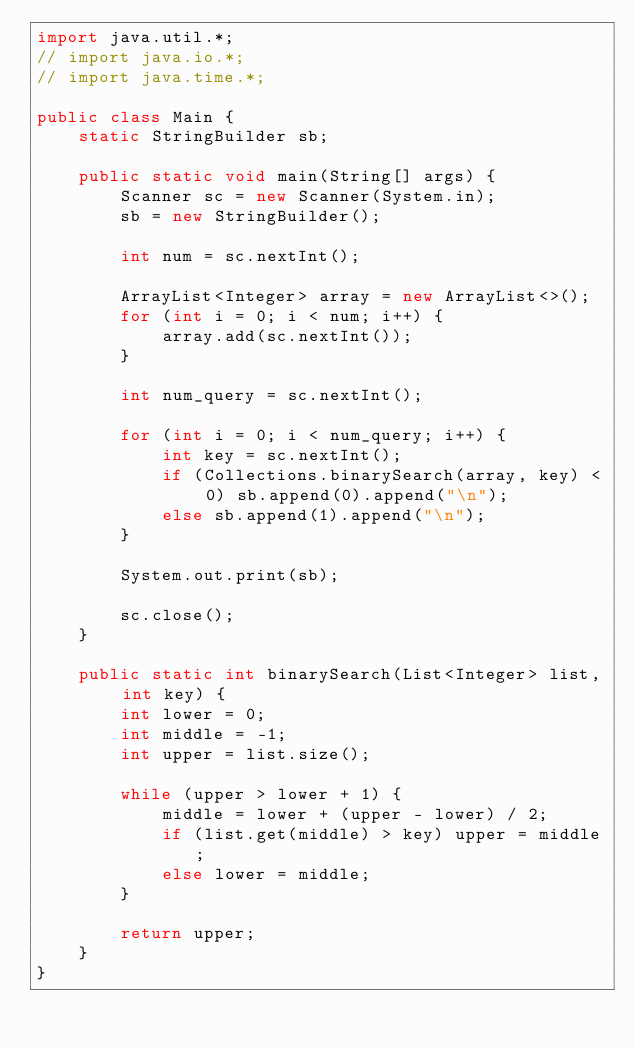Convert code to text. <code><loc_0><loc_0><loc_500><loc_500><_Java_>import java.util.*;
// import java.io.*;
// import java.time.*;

public class Main {
    static StringBuilder sb;

    public static void main(String[] args) {
        Scanner sc = new Scanner(System.in);
        sb = new StringBuilder();

        int num = sc.nextInt();

        ArrayList<Integer> array = new ArrayList<>();
        for (int i = 0; i < num; i++) {
            array.add(sc.nextInt());
        }

        int num_query = sc.nextInt();

        for (int i = 0; i < num_query; i++) {
            int key = sc.nextInt();
            if (Collections.binarySearch(array, key) < 0) sb.append(0).append("\n");
            else sb.append(1).append("\n");
        }

        System.out.print(sb);
        
        sc.close();
    }

    public static int binarySearch(List<Integer> list, int key) {
        int lower = 0;
        int middle = -1;
        int upper = list.size();

        while (upper > lower + 1) {
            middle = lower + (upper - lower) / 2;
            if (list.get(middle) > key) upper = middle;
            else lower = middle;
        }

        return upper;
    }
}

</code> 